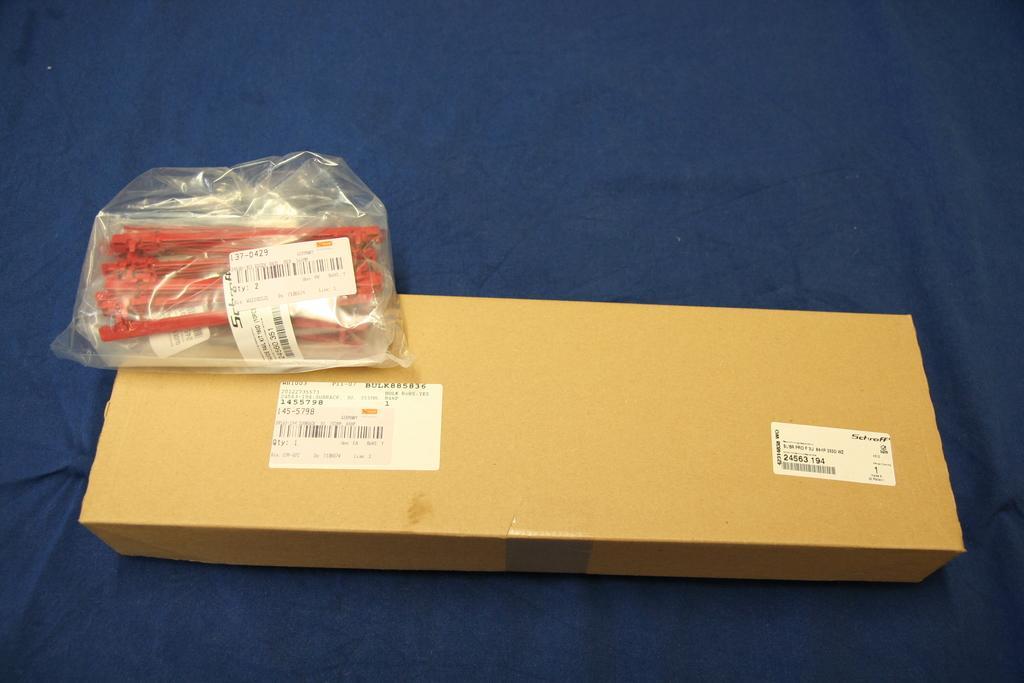Can you describe this image briefly? In this image, we can see a table, on that table, we can see a blue colored cloth and a box and a cover. In the cover, we can see few instruments. 